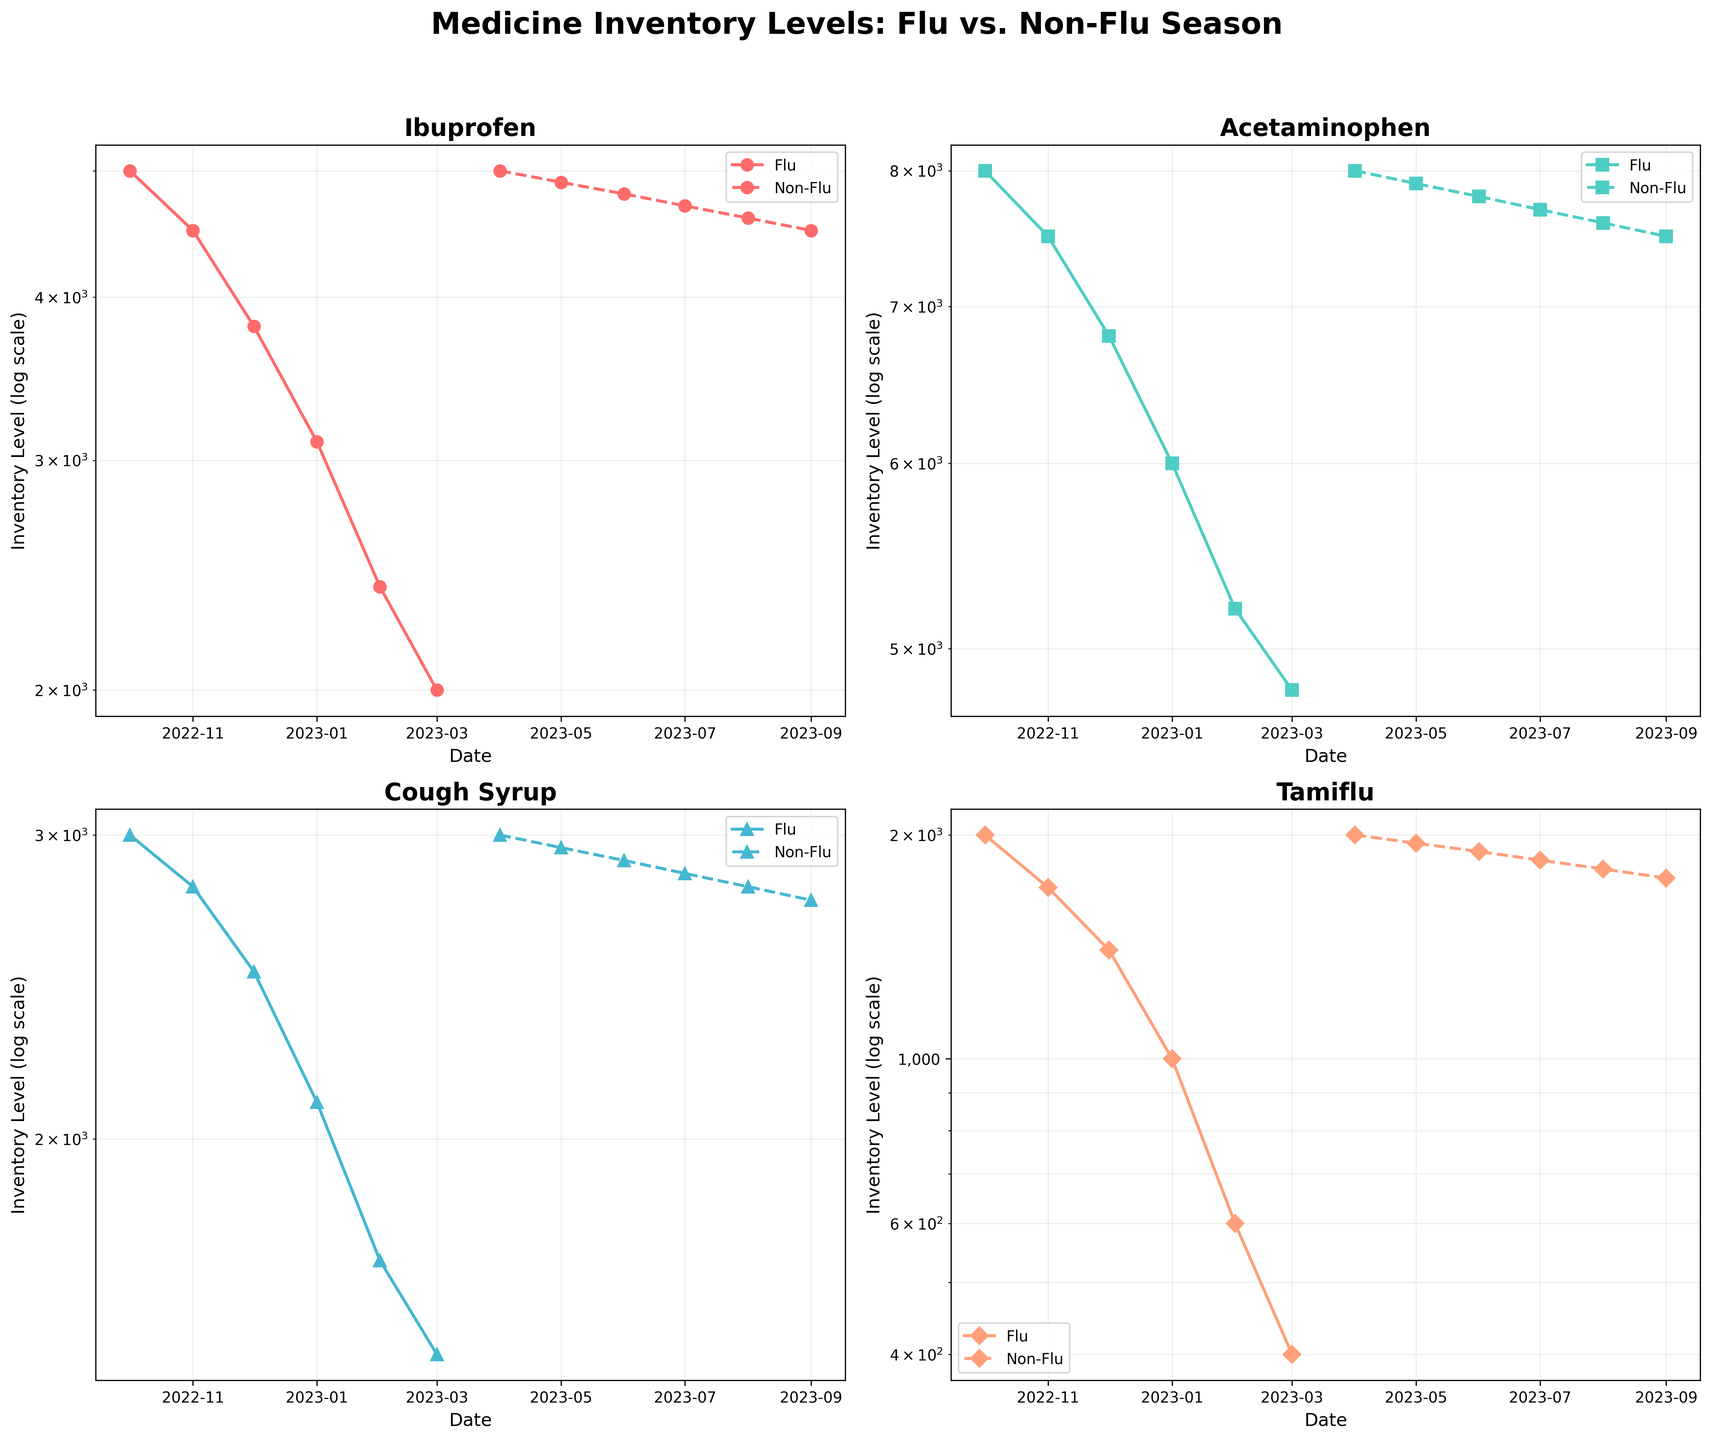What is the title of the figure? The title of the figure is located at the top and typically describes the overall content or purpose of the figure. This helps the viewer quickly understand the context. In this case, the title indicates the comparison between flu and non-flu season medicine inventory levels.
Answer: Medicine Inventory Levels: Flu vs. Non-Flu Season How have inventory levels for Ibuprofen changed from October 2022 to March 2023 during the flu season? To answer this question, observe the plot for Ibuprofen during the flu season (with a solid line). The inventory levels start at 5000 in October 2022 and decrease to 2000 by March 2023.
Answer: Decreased from 5000 to 2000 Which medicine shows the most significant decrease in inventory levels during the flu season? Evaluate the subplots for all medicines during the flu season by looking at the slopes of the solid lines. Tamiflu shows the steepest decline, from 2000 to 400, indicating the most significant decrease in inventory levels.
Answer: Tamiflu What is the inventory level of Acetaminophen in May 2023 during the non-flu season? Find the subplot for Acetaminophen and locate the data point for May 2023 during the non-flu season (dashed line). The inventory level is approximately 7900.
Answer: 7900 During which month does Cough Syrup inventory level reach its lowest point during the flu season? In the subplot for Cough Syrup during the flu season (solid line), look for the lowest y-axis value. This occurs in March 2023, where the inventory level is around 1500.
Answer: March 2023 Compare the slopes of inventory levels for Tamiflu and Ibuprofen during the non-flu season. Which one has a steeper slope? Looking at the dashed lines in the subplots for both Tamiflu and Ibuprofen during the non-flu season, observe the change over time. Tamiflu's line is steeper compared to Ibuprofen's, indicating a faster decrease in inventory levels.
Answer: Tamiflu What can you infer about the inventory levels of Cough Syrup between the flu and non-flu seasons? Compare the solid and dashed lines in the Cough Syrup subplot. During the flu season, inventory levels drop significantly. In contrast, during the non-flu season, the levels are more stable with a slight decrease.
Answer: Significant drop during flu season; stable with slight decrease during non-flu season What is the inventory level of Tamiflu in January 2023 during the flu season? In the Tamiflu subplot, locate the January 2023 point during the flu season (solid line). The inventory level is around 1000.
Answer: 1000 How do the inventory levels of Acetaminophen change between October 2022 and April 2023? In the Acetaminophen subplot, observe the solid line for October 2022 to March 2023 (flu season) and the start of the dashed line in April 2023 (non-flu season). Inventory levels decrease from 8000 to 4800 and then reset to 8000.
Answer: Decrease from 8000 to 4800 and reset to 8000 